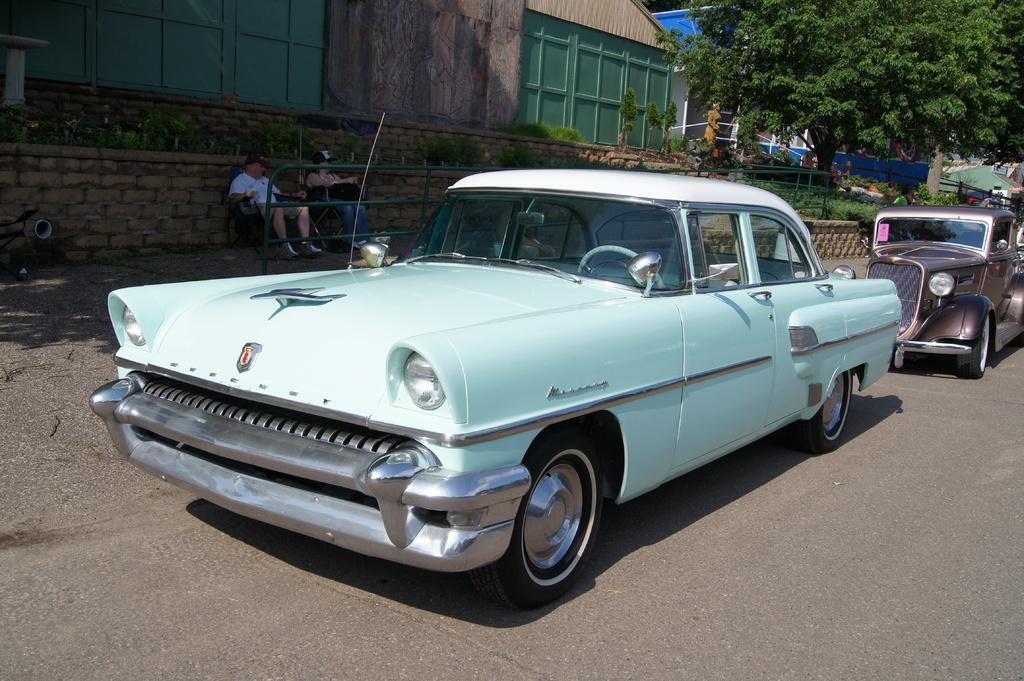Could you give a brief overview of what you see in this image? In this image we can see there are cars on the road. And there are buildings, trees, plants, statue and fence. And there are two people sitting on the chair. 